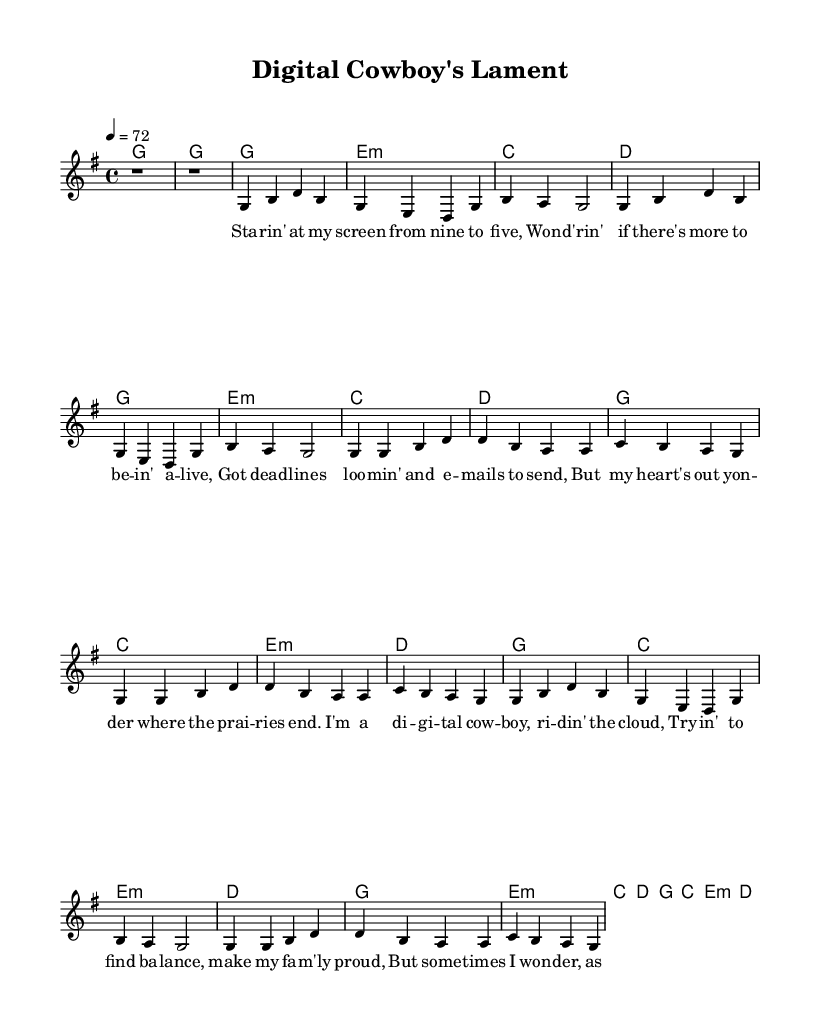What is the key signature of this music? The key signature indicated in the global section of the code is G major, which has one sharp (F#).
Answer: G major What is the time signature of this music? The time signature is specified in the global section of the code as 4/4, meaning there are four beats in each measure and a quarter note receives one beat.
Answer: 4/4 What is the tempo marking of this piece? The tempo marking indicated is "4 = 72", which means there are 72 beats per minute. This is noted in the global section of the code.
Answer: 72 How many verses are there in this composition? The provided music includes two verses indicated by separate verses in the melody and lyrics; the second verse is abbreviated.
Answer: Two What is the main theme explored in the lyrics? The lyrics focus on the struggle to find a balance between work and personal life, reflecting on the challenges faced by a "digital cowboy." This theme is evident in the content of both verses and the chorus.
Answer: Balance What is the structure of the piece? The structure consists of an intro, followed by verse one, chorus, verse two (abbreviated), and then a repeat of the chorus (abbreviated). This order is common in country ballads where narrative progression is key.
Answer: Verse-Chorus format What instrument typically plays the lead melody? The lead melody is generally performed on a guitar or similar string instrument, which is common in country music due to its acoustic nature and the genre's traditional roots.
Answer: Guitar 